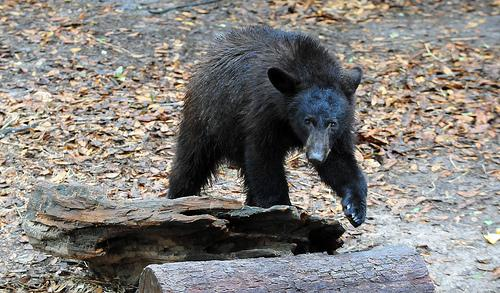Question: when was the picture taken?
Choices:
A. At night.
B. Sunrise.
C. Sunset.
D. During the day.
Answer with the letter. Answer: D Question: what is on the ground?
Choices:
A. Snow.
B. Dogs.
C. Trash.
D. Leaves.
Answer with the letter. Answer: D Question: who is the animal in the picture?
Choices:
A. A dog.
B. A cow.
C. Turtles.
D. A bear.
Answer with the letter. Answer: D Question: what color eyes are the bears eyes?
Choices:
A. Brown.
B. Blue.
C. Green.
D. Black.
Answer with the letter. Answer: D Question: what color is the wood?
Choices:
A. Black.
B. Brown.
C. White.
D. Grey.
Answer with the letter. Answer: B 